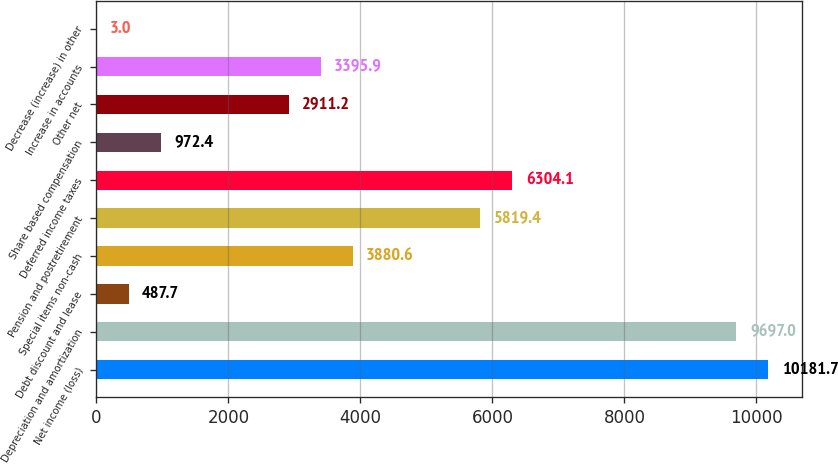Convert chart to OTSL. <chart><loc_0><loc_0><loc_500><loc_500><bar_chart><fcel>Net income (loss)<fcel>Depreciation and amortization<fcel>Debt discount and lease<fcel>Special items non-cash<fcel>Pension and postretirement<fcel>Deferred income taxes<fcel>Share based compensation<fcel>Other net<fcel>Increase in accounts<fcel>Decrease (increase) in other<nl><fcel>10181.7<fcel>9697<fcel>487.7<fcel>3880.6<fcel>5819.4<fcel>6304.1<fcel>972.4<fcel>2911.2<fcel>3395.9<fcel>3<nl></chart> 